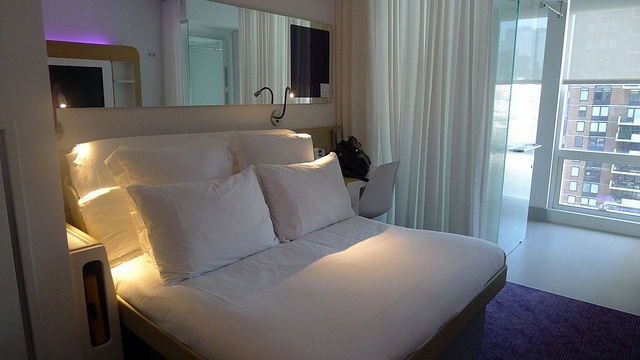Describe the objects in this image and their specific colors. I can see bed in gray and tan tones, chair in gray and black tones, and backpack in gray and black tones in this image. 